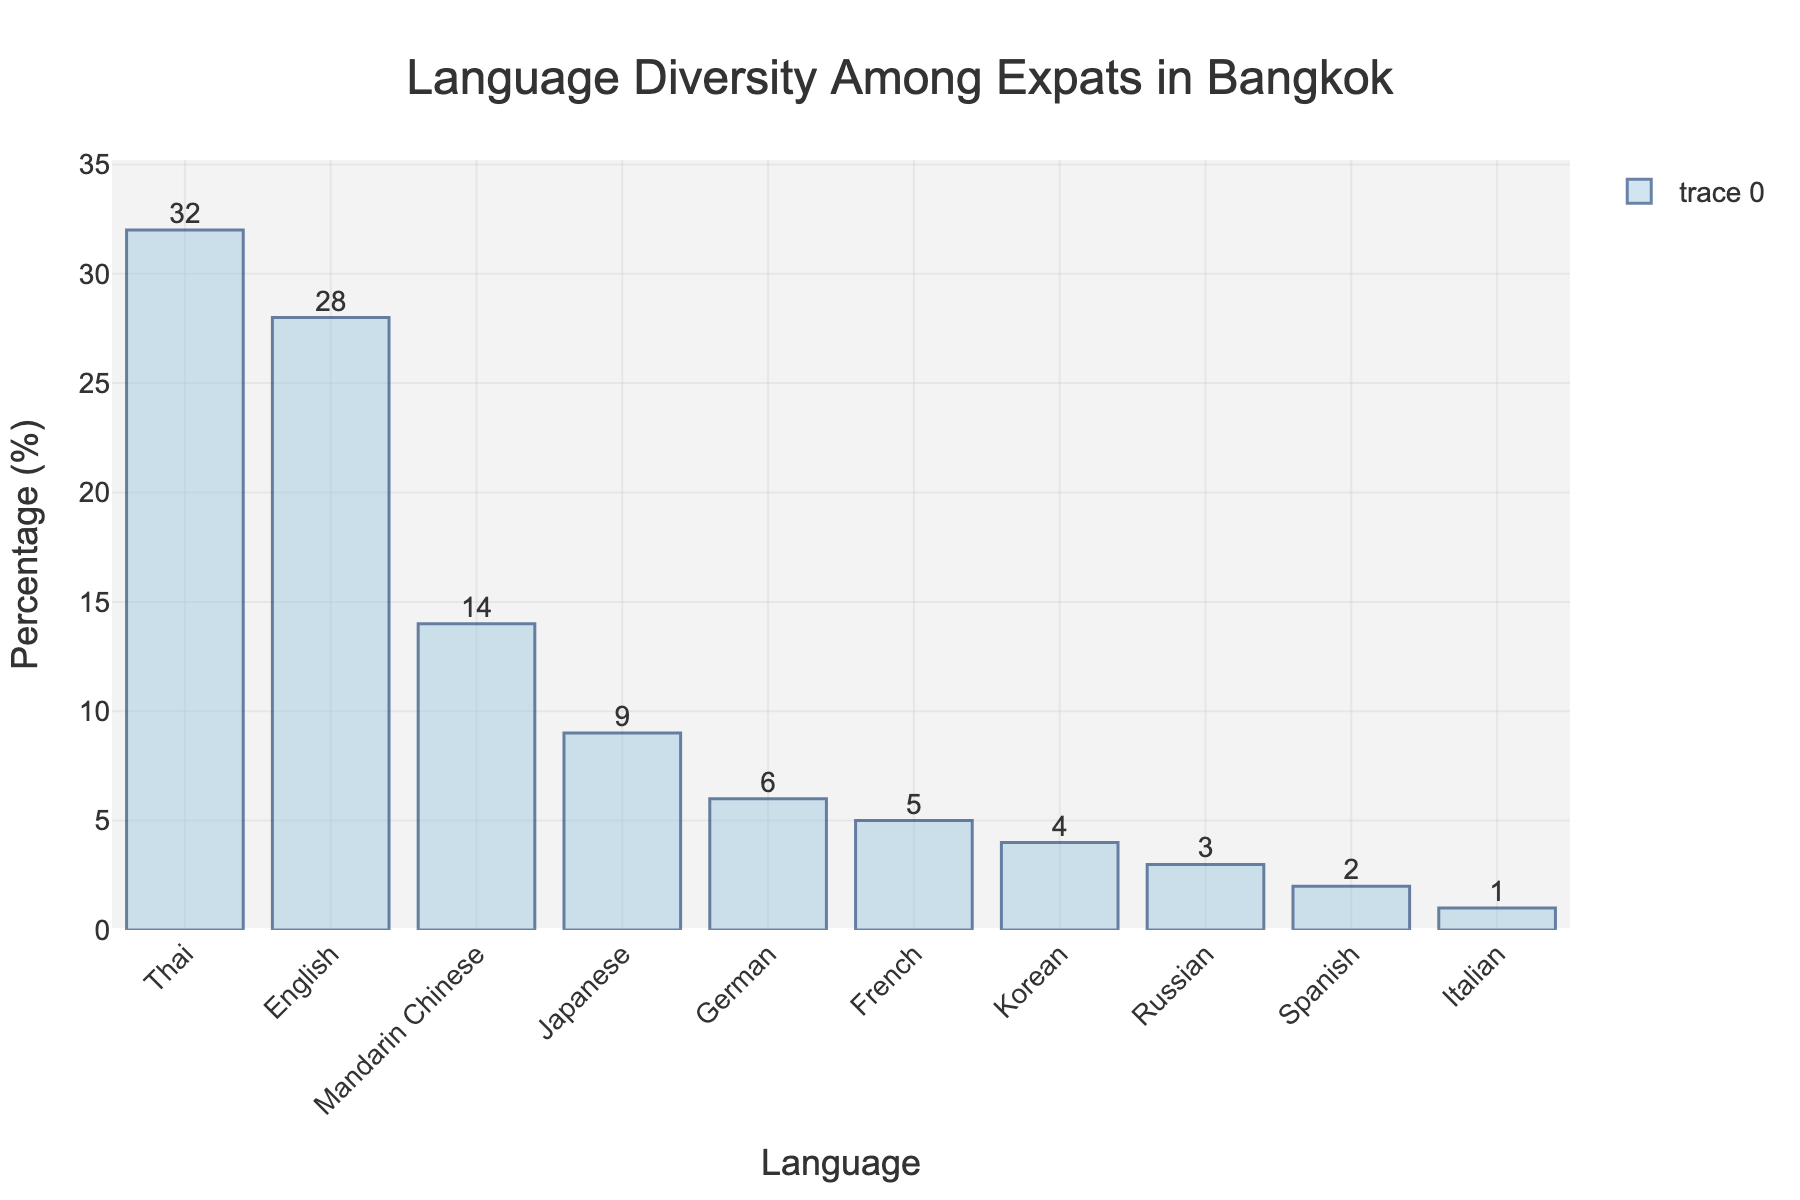what is the most common language among expats in Bangkok's off-the-beaten-path areas? The tallest bar in the bar chart represents the language with the highest percentage. This is visually identified as the bar labeled "Thai" at 32%.
Answer: Thai What percentage of expats speak Mandarin Chinese and Korean combined? Sum the percentage of expats speaking Mandarin Chinese (14%) and Korean (4%). 14% + 4% = 18%.
Answer: 18% Compare the percentage of expats who speak Japanese and German. Which language is more common? Look at the bars for Japanese and German. The percentage for Japanese is 9%, while the percentage for German is 6%. Since 9% is greater than 6%, Japanese is more common.
Answer: Japanese What is the total percentage of expat languages that have a percentage of 5% or less? Sum the percentages of languages with bars at or below 5%. These are French (5%), Korean (4%), Russian (3%), Spanish (2%), and Italian (1%). 5% + 4% + 3% + 2% + 1% = 15%.
Answer: 15% Which languages are spoken by less than 5% of expats? Identify the languages with bars representing percentages less than 5%. These are Korean, Russian, Spanish, and Italian.
Answer: Korean, Russian, Spanish, and Italian Is the percentage of expats who speak English higher, lower, or equal to the percentage of expats who speak Mandarin Chinese and Japanese combined? Check the percentage bars for English (28%), and sum the percentages for Mandarin Chinese (14%) and Japanese (9%). 14% + 9% = 23%. Since 28% > 23%, the percentage of English speakers is higher.
Answer: Higher What is the range of percentage values represented in the chart? Identify the minimum and maximum percentage values. The smallest value is 1% (Italian) and the largest is 32% (Thai). The range is 32% - 1% = 31%.
Answer: 31% Compare the total percentage of expats who speak European languages (German, French, Russian, Spanish, and Italian) to those who speak Asian languages (Thai, Mandarin Chinese, Japanese, Korean). Which group has a higher total percentage? Sum the percentages of European languages: German (6%) + French (5%) + Russian (3%) + Spanish (2%) + Italian (1%) = 17%. Sum the percentages of Asian languages: Thai (32%) + Mandarin Chinese (14%) + Japanese (9%) + Korean (4%) = 59%. Since 59% > 17%, Asian languages have a higher total percentage.
Answer: Asian languages What's the median percentage of all listed languages? Arrange the percentages in ascending order: 1%, 2%, 3%, 4%, 5%, 6%, 9%, 14%, 28%, 32%. The median value, being the average of the 5th and 6th values, is (5% + 6%)/2 = 5.5%.
Answer: 5.5% What is the difference in percentage between the most and least spoken languages? Identify the highest (Thai at 32%) and the lowest (Italian at 1%) percentages. The difference is 32% - 1% = 31%.
Answer: 31% 